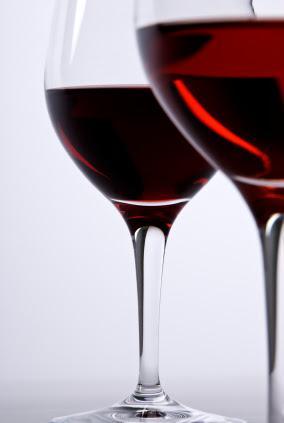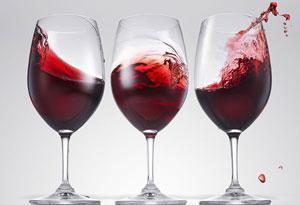The first image is the image on the left, the second image is the image on the right. For the images displayed, is the sentence "The image on the right has three glasses of red wine." factually correct? Answer yes or no. Yes. The first image is the image on the left, the second image is the image on the right. Considering the images on both sides, is "Left image shows exactly three half-full wine glasses arranged in a row." valid? Answer yes or no. No. 